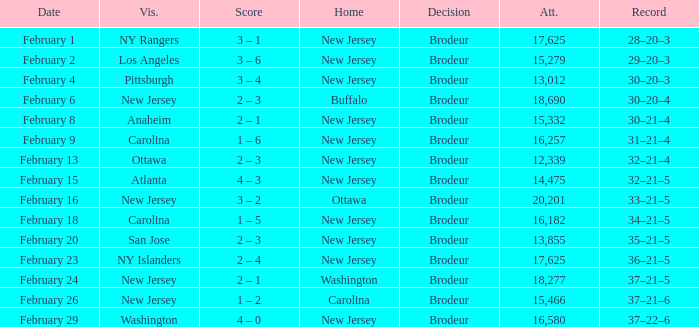What was the score when the NY Islanders was the visiting team? 2 – 4. 